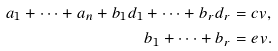Convert formula to latex. <formula><loc_0><loc_0><loc_500><loc_500>a _ { 1 } + \dots + a _ { n } + b _ { 1 } d _ { 1 } + \dots + b _ { r } d _ { r } & = c v , \\ b _ { 1 } + \dots + b _ { r } & = e v .</formula> 